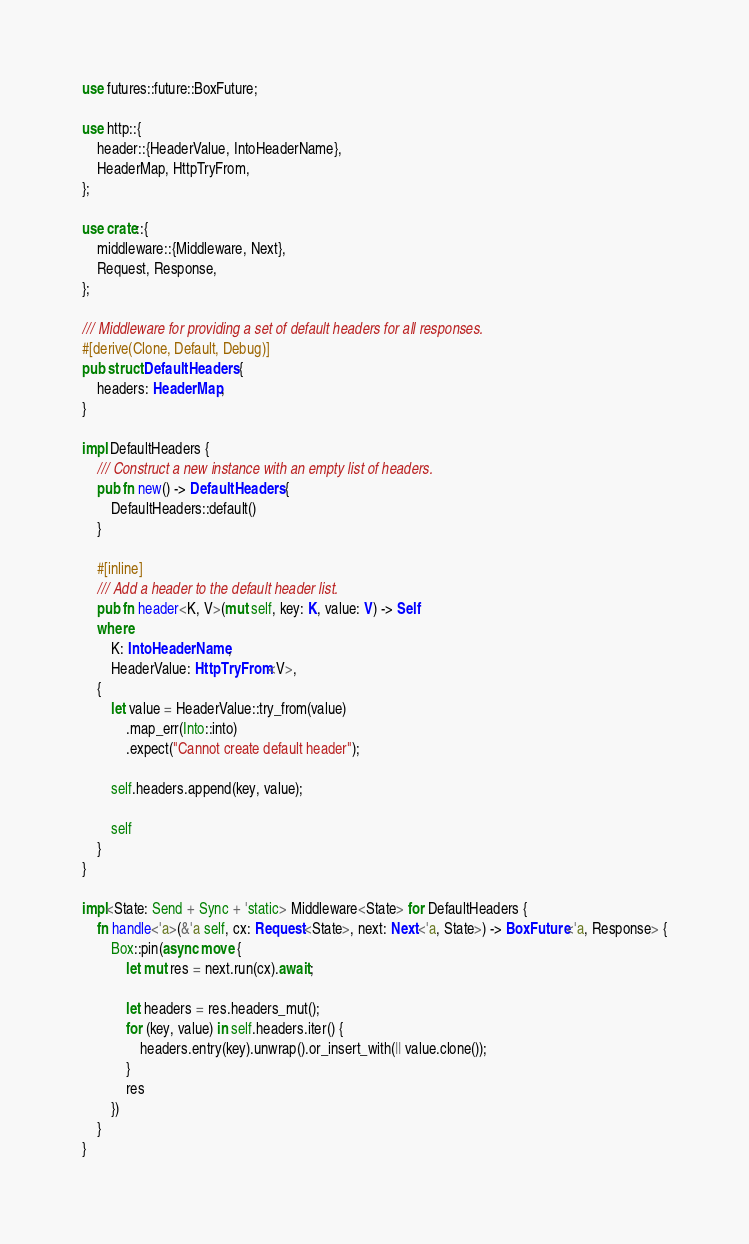<code> <loc_0><loc_0><loc_500><loc_500><_Rust_>use futures::future::BoxFuture;

use http::{
    header::{HeaderValue, IntoHeaderName},
    HeaderMap, HttpTryFrom,
};

use crate::{
    middleware::{Middleware, Next},
    Request, Response,
};

/// Middleware for providing a set of default headers for all responses.
#[derive(Clone, Default, Debug)]
pub struct DefaultHeaders {
    headers: HeaderMap,
}

impl DefaultHeaders {
    /// Construct a new instance with an empty list of headers.
    pub fn new() -> DefaultHeaders {
        DefaultHeaders::default()
    }

    #[inline]
    /// Add a header to the default header list.
    pub fn header<K, V>(mut self, key: K, value: V) -> Self
    where
        K: IntoHeaderName,
        HeaderValue: HttpTryFrom<V>,
    {
        let value = HeaderValue::try_from(value)
            .map_err(Into::into)
            .expect("Cannot create default header");

        self.headers.append(key, value);

        self
    }
}

impl<State: Send + Sync + 'static> Middleware<State> for DefaultHeaders {
    fn handle<'a>(&'a self, cx: Request<State>, next: Next<'a, State>) -> BoxFuture<'a, Response> {
        Box::pin(async move {
            let mut res = next.run(cx).await;

            let headers = res.headers_mut();
            for (key, value) in self.headers.iter() {
                headers.entry(key).unwrap().or_insert_with(|| value.clone());
            }
            res
        })
    }
}
</code> 